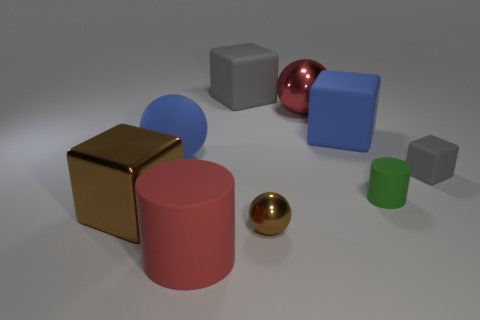Subtract all gray blocks. How many were subtracted if there are1gray blocks left? 1 Add 1 rubber balls. How many objects exist? 10 Subtract all green cylinders. How many cylinders are left? 1 Subtract all metal spheres. How many spheres are left? 1 Subtract all metallic cubes. Subtract all blue matte objects. How many objects are left? 6 Add 4 small green cylinders. How many small green cylinders are left? 5 Add 7 big gray blocks. How many big gray blocks exist? 8 Subtract 0 purple spheres. How many objects are left? 9 Subtract all blocks. How many objects are left? 5 Subtract 3 balls. How many balls are left? 0 